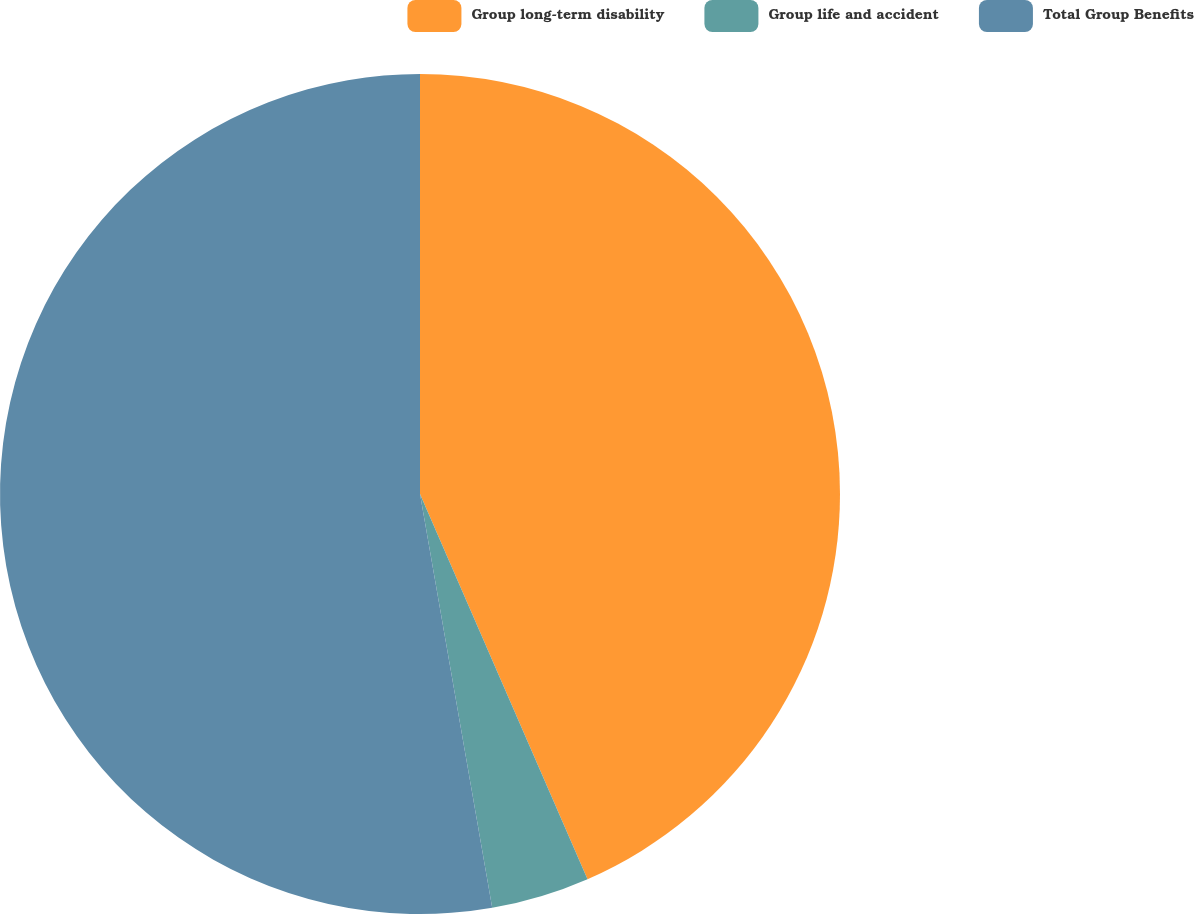Convert chart to OTSL. <chart><loc_0><loc_0><loc_500><loc_500><pie_chart><fcel>Group long-term disability<fcel>Group life and accident<fcel>Total Group Benefits<nl><fcel>43.47%<fcel>3.78%<fcel>52.75%<nl></chart> 